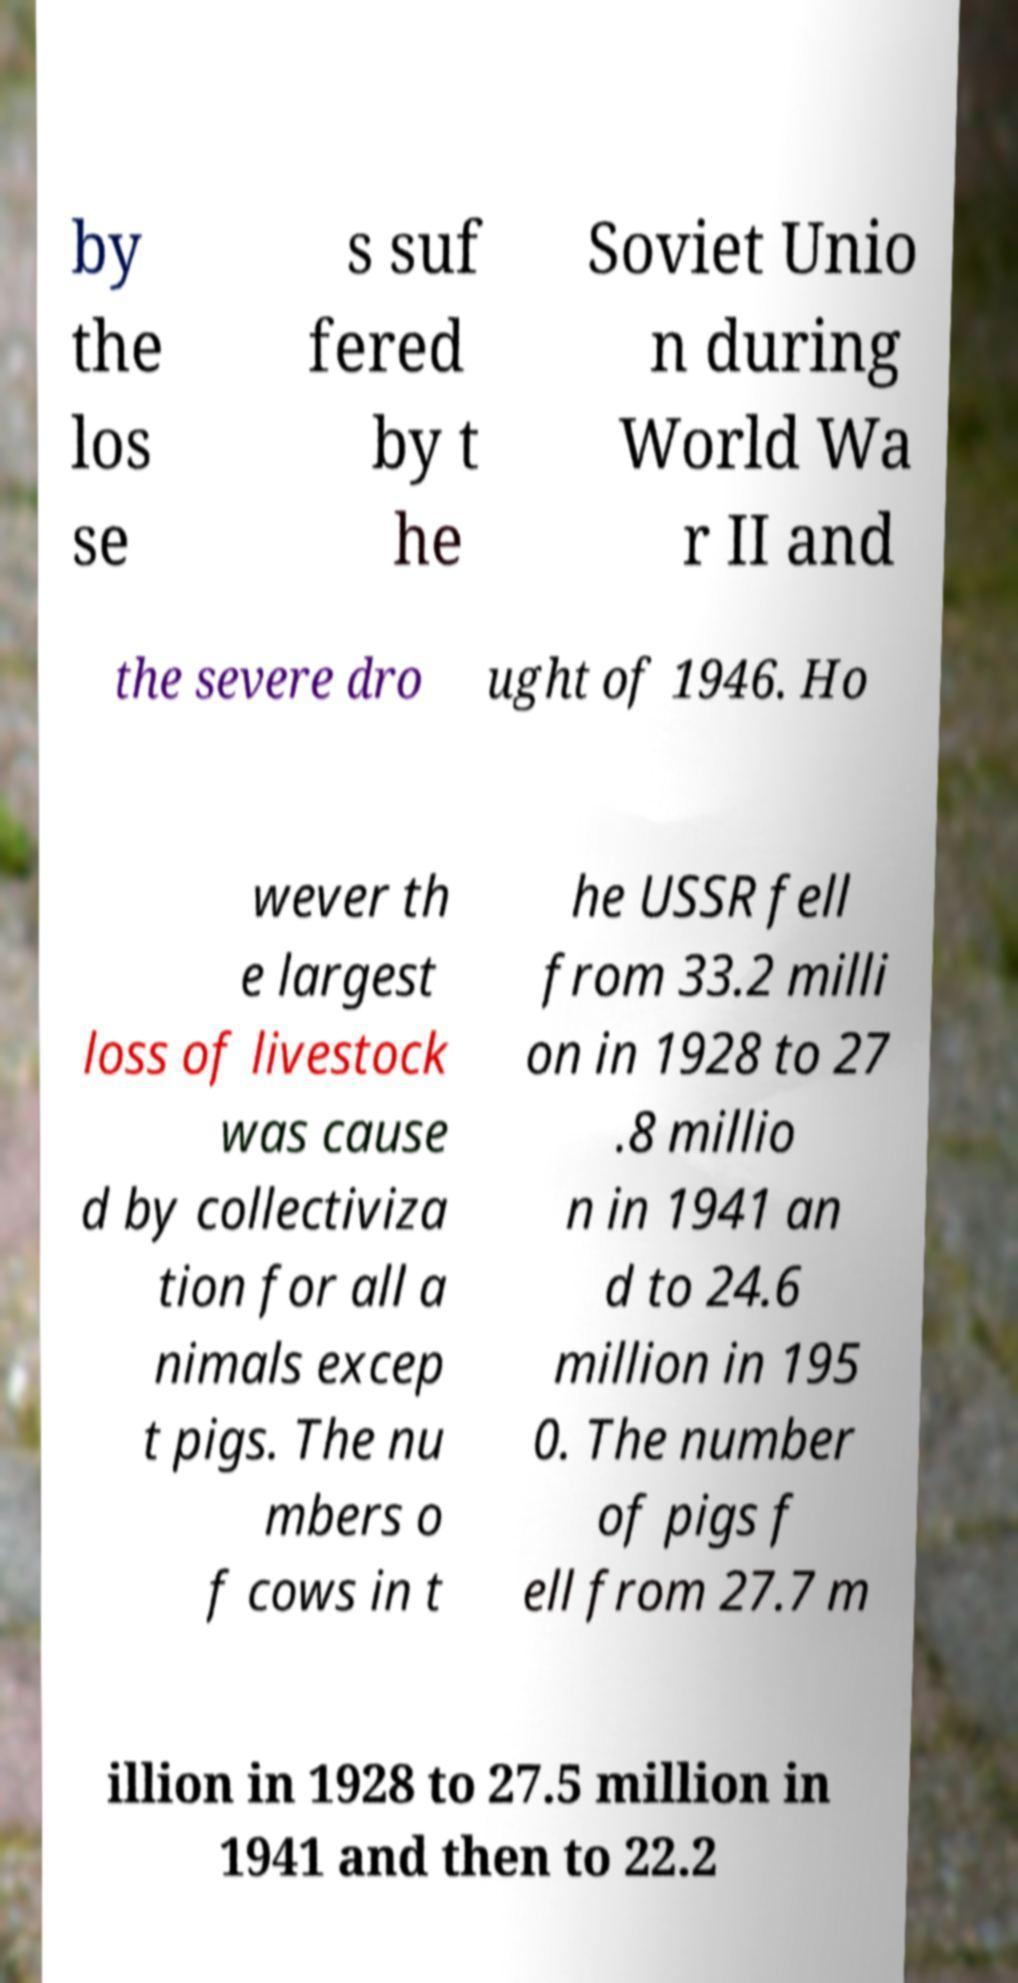For documentation purposes, I need the text within this image transcribed. Could you provide that? by the los se s suf fered by t he Soviet Unio n during World Wa r II and the severe dro ught of 1946. Ho wever th e largest loss of livestock was cause d by collectiviza tion for all a nimals excep t pigs. The nu mbers o f cows in t he USSR fell from 33.2 milli on in 1928 to 27 .8 millio n in 1941 an d to 24.6 million in 195 0. The number of pigs f ell from 27.7 m illion in 1928 to 27.5 million in 1941 and then to 22.2 